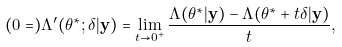<formula> <loc_0><loc_0><loc_500><loc_500>( 0 = ) \Lambda ^ { \prime } ( \theta ^ { * } ; \delta | { \mathbf y } ) = \lim _ { t \rightarrow 0 ^ { + } } \frac { \Lambda ( \theta ^ { * } | { \mathbf y } ) - \Lambda ( \theta ^ { * } + t \delta | { \mathbf y } ) } { t } ,</formula> 